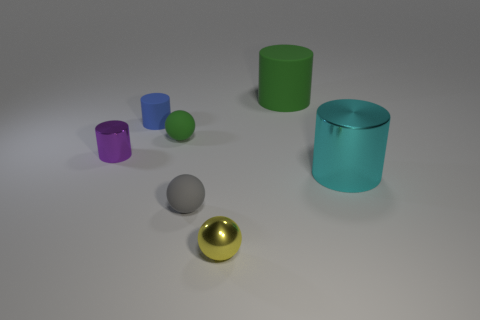What is the material of the tiny ball that is the same color as the large matte cylinder?
Offer a terse response. Rubber. There is a metal thing that is in front of the large cyan cylinder; what is its shape?
Offer a very short reply. Sphere. How many tiny things are there?
Give a very brief answer. 5. There is a tiny cylinder that is made of the same material as the large green thing; what is its color?
Offer a terse response. Blue. How many large objects are either blue rubber balls or yellow things?
Keep it short and to the point. 0. What number of tiny purple cylinders are in front of the yellow metal ball?
Ensure brevity in your answer.  0. What is the color of the other big thing that is the same shape as the big green object?
Make the answer very short. Cyan. What number of shiny objects are red blocks or gray balls?
Offer a very short reply. 0. Are there any cyan metallic things that are behind the large object in front of the green object behind the blue matte cylinder?
Ensure brevity in your answer.  No. The metal sphere has what color?
Ensure brevity in your answer.  Yellow. 